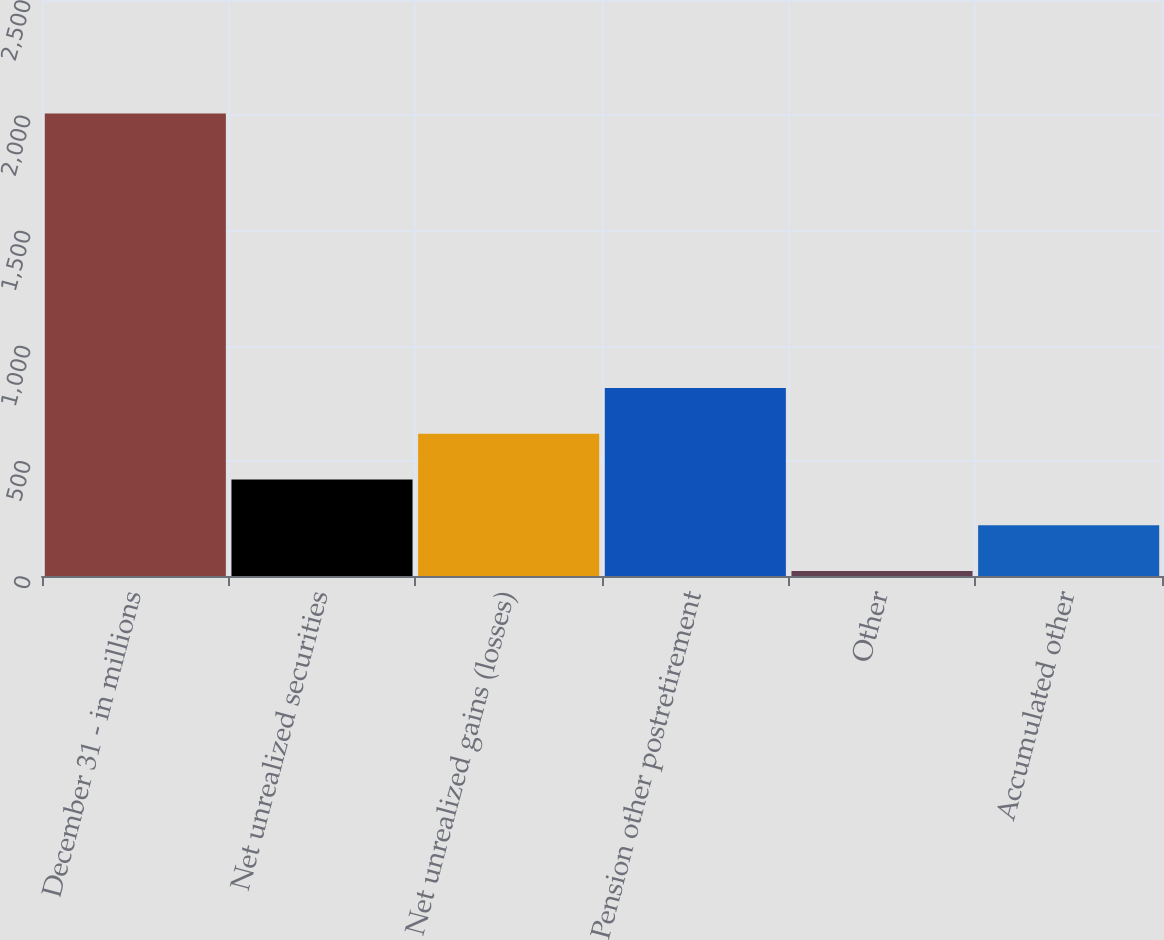Convert chart to OTSL. <chart><loc_0><loc_0><loc_500><loc_500><bar_chart><fcel>December 31 - in millions<fcel>Net unrealized securities<fcel>Net unrealized gains (losses)<fcel>Pension other postretirement<fcel>Other<fcel>Accumulated other<nl><fcel>2007<fcel>419<fcel>617.5<fcel>816<fcel>22<fcel>220.5<nl></chart> 